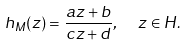Convert formula to latex. <formula><loc_0><loc_0><loc_500><loc_500>h _ { M } ( z ) = \frac { a z + b } { c z + d } , \ \ z \in H .</formula> 